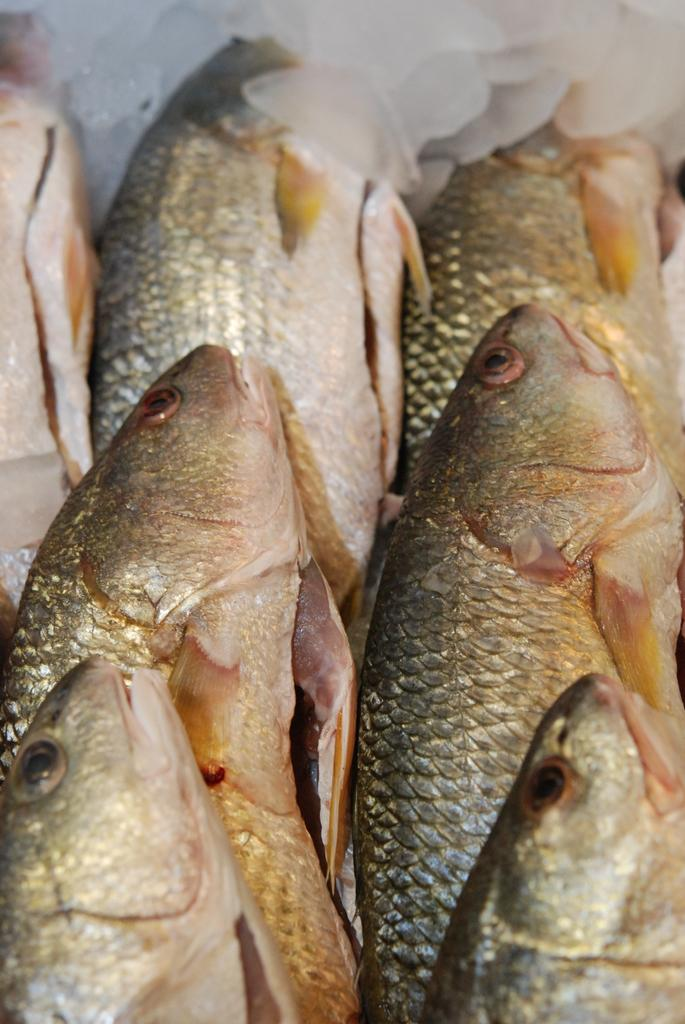What type of animals can be seen in the image? There are fish in the image. Can you describe the color pattern of the fish? The fish have brown and cream colors. What type of tree can be seen in the image? There is no tree present in the image; it features fish with brown and cream colors. What kind of test is being conducted in the image? There is no test being conducted in the image; it features fish with brown and cream colors. 